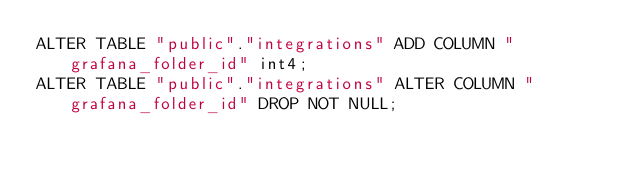<code> <loc_0><loc_0><loc_500><loc_500><_SQL_>ALTER TABLE "public"."integrations" ADD COLUMN "grafana_folder_id" int4;
ALTER TABLE "public"."integrations" ALTER COLUMN "grafana_folder_id" DROP NOT NULL;
</code> 